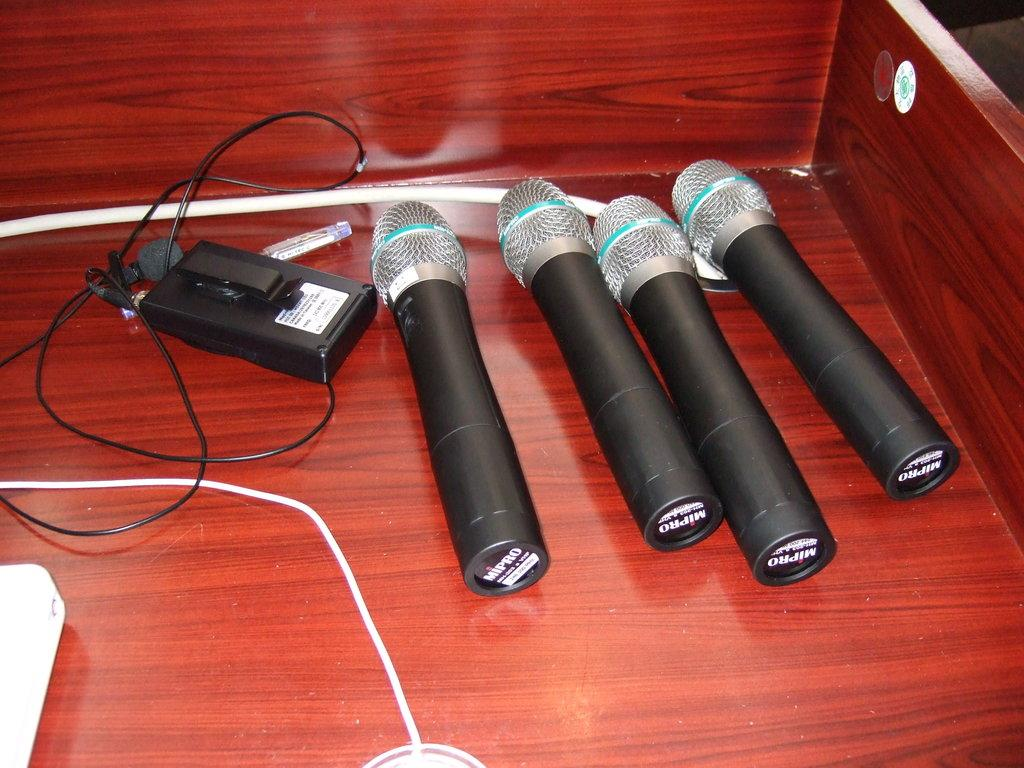How many microphones are visible in the image? There are four microphones in the image. What other electronic device can be seen in the image? There is an electronic device with wires in the image. What type of surface are the microphones and electronic device placed on? The microphones and electronic device are on a wooden surface. What type of cast can be seen on the body of the person in the image? There is no person present in the image, and therefore no cast can be seen on any body. 